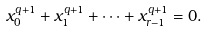Convert formula to latex. <formula><loc_0><loc_0><loc_500><loc_500>x _ { 0 } ^ { q + 1 } + x _ { 1 } ^ { q + 1 } + \dots + x _ { r - 1 } ^ { q + 1 } = 0 .</formula> 